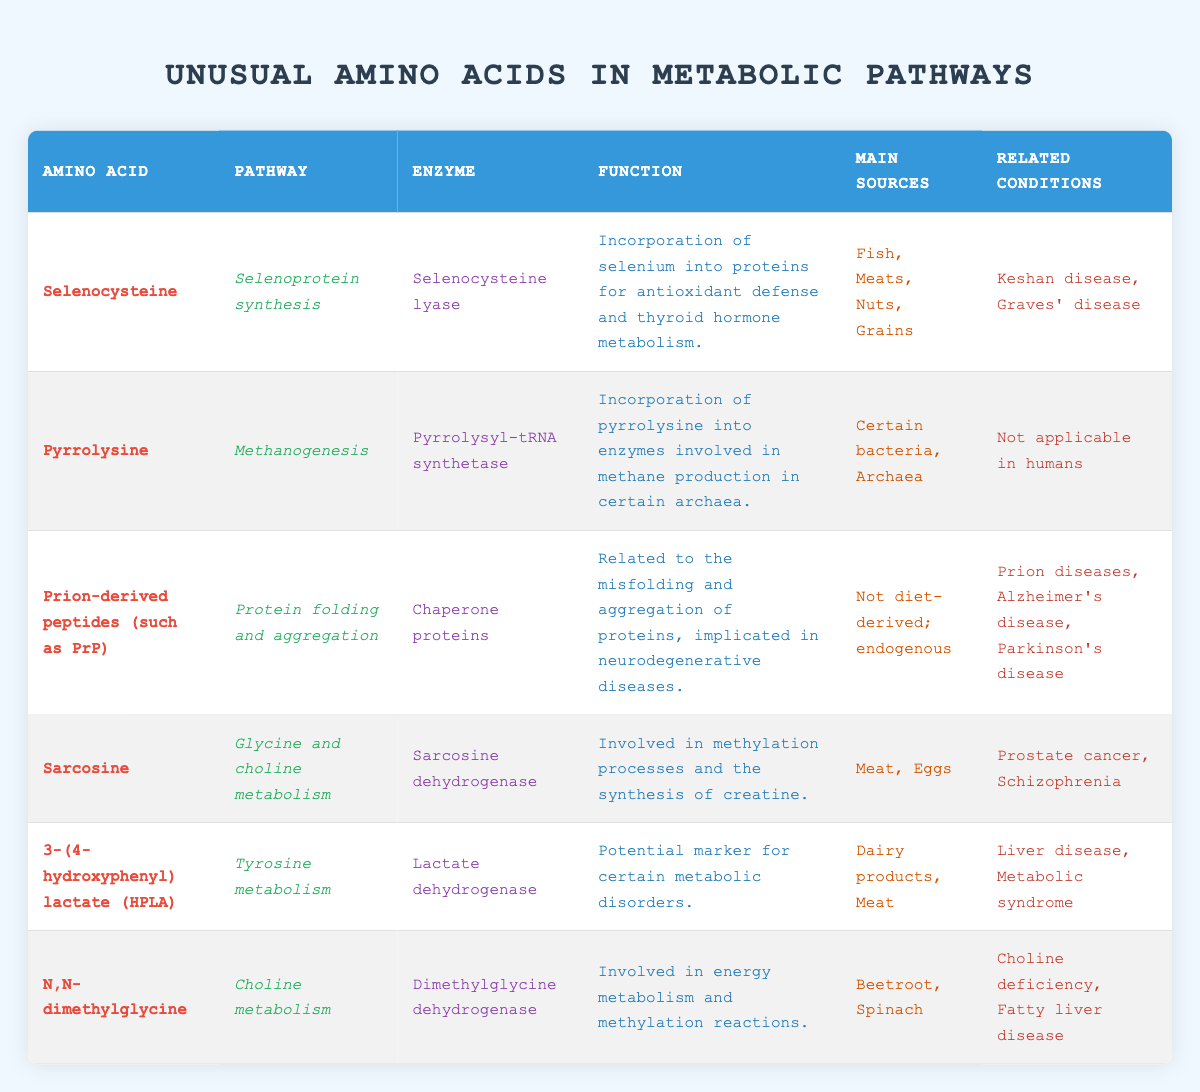What is the metabolic pathway for Selenocysteine? The table directly lists Selenocysteine under the 'Amino Acid' column, and the corresponding pathway noted in the 'Pathway' column is 'Selenoprotein synthesis.'
Answer: Selenoprotein synthesis Which enzyme is involved in the metabolism of Sarcosine? From the table, Sarcosine is listed in the first column, and its associated enzyme, found in the 'Enzyme' column, is 'Sarcosine dehydrogenase.'
Answer: Sarcosine dehydrogenase Are Pyrrolysine-related conditions applicable to humans? The 'Related Conditions' column under the row for Pyrrolysine states 'Not applicable in humans,' clearly indicating that there are no related conditions for humans.
Answer: No What are the main sources of N,N-dimethylglycine? Looking at the row for N,N-dimethylglycine in the table, the 'Main Sources' column lists 'Beetroot, Spinach,' which are the specific sources mentioned.
Answer: Beetroot, Spinach Which unusual amino acid is implicated in neurodegenerative diseases? The table shows that Prion-derived peptides (such as PrP) are related to protein folding and aggregation, with 'Prion diseases, Alzheimer's disease, Parkinson's disease' listed under 'Related Conditions.' Thus, it is clear that this amino acid is involved in those conditions.
Answer: Prion-derived peptides (such as PrP) What is the function of Selenocysteine in human metabolism? By examining the 'Function' column associated with Selenocysteine in the table, it states that its role is the incorporation of selenium into proteins for antioxidant defense and thyroid hormone metabolism.
Answer: Incorporation of selenium into proteins for antioxidant defense and thyroid hormone metabolism How many amino acids listed in the table have related conditions included? Counting the entries with conditions, Selenocysteine, Prion-derived peptides, Sarcosine, 3-(4-hydroxyphenyl) lactate, and N,N-dimethylglycine all show related conditions. Thus, 5 out of the 6 amino acids have related conditions listed.
Answer: 5 Is Sarcosine associated with any cancer-related condition? The table states under 'Related Conditions' that Sarcosine is linked to 'Prostate cancer,' confirming that it is indeed associated with a cancer-related condition.
Answer: Yes Which amino acid is synthesized from dietary sources that include dairy products and meat? The table indicates that 3-(4-hydroxyphenyl) lactate (HPLA) has 'Dairy products, Meat' as its main sources of intake, thus confirming it is synthesized from these dietary sources.
Answer: 3-(4-hydroxyphenyl) lactate (HPLA) 